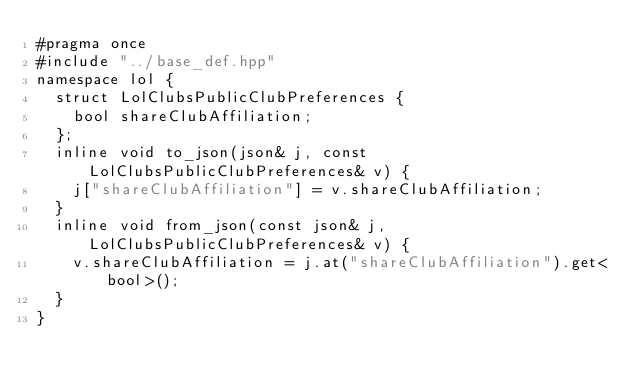Convert code to text. <code><loc_0><loc_0><loc_500><loc_500><_C++_>#pragma once
#include "../base_def.hpp" 
namespace lol {
  struct LolClubsPublicClubPreferences { 
    bool shareClubAffiliation; 
  };
  inline void to_json(json& j, const LolClubsPublicClubPreferences& v) {
    j["shareClubAffiliation"] = v.shareClubAffiliation; 
  }
  inline void from_json(const json& j, LolClubsPublicClubPreferences& v) {
    v.shareClubAffiliation = j.at("shareClubAffiliation").get<bool>(); 
  }
}</code> 